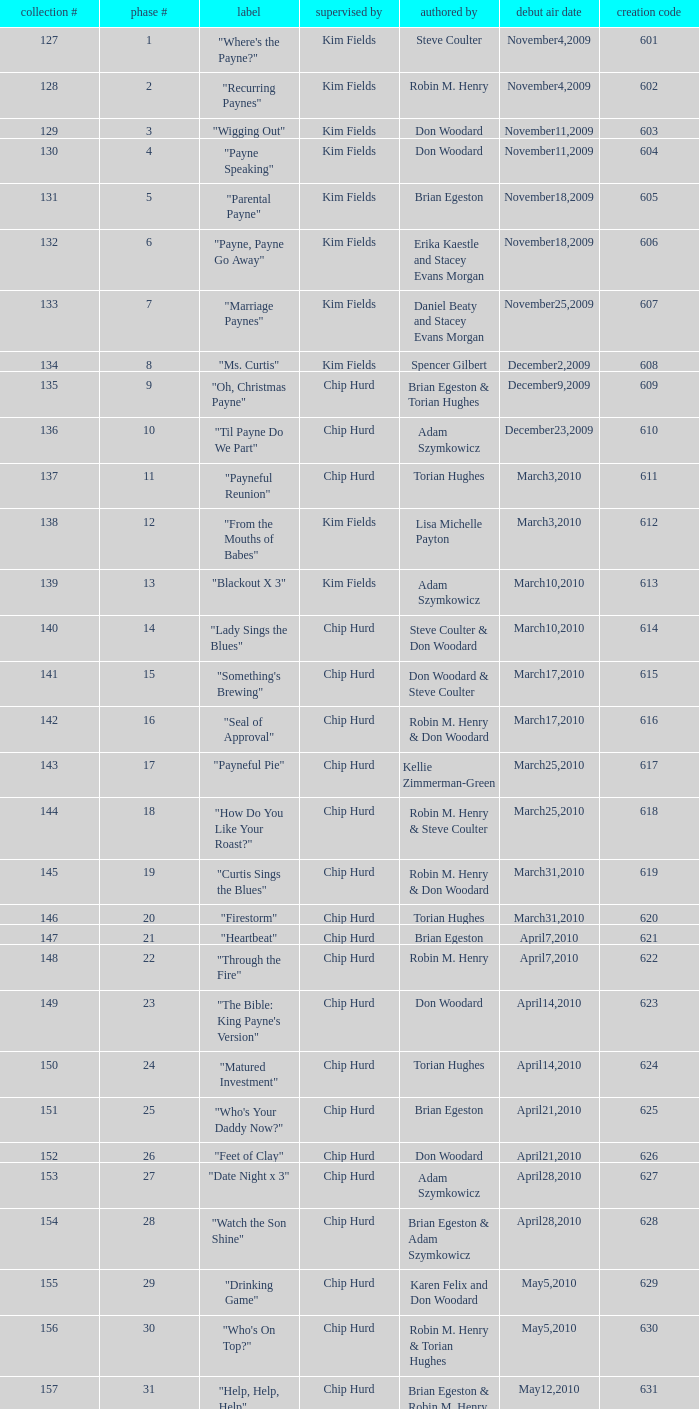What is the original air date of the episode written by Karen Felix and Don Woodard? May5,2010. 